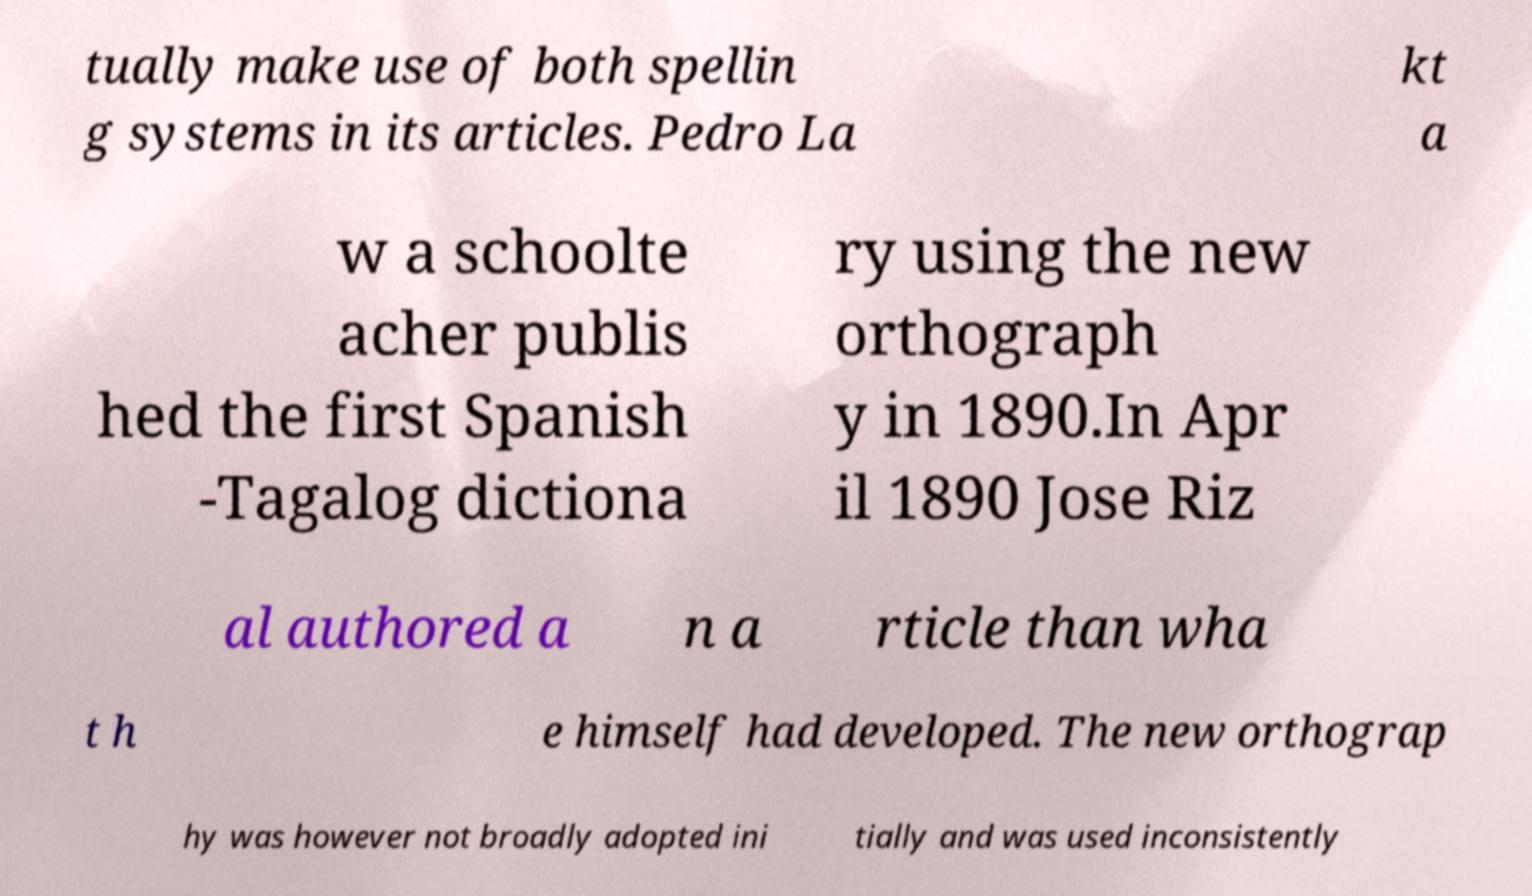Please identify and transcribe the text found in this image. tually make use of both spellin g systems in its articles. Pedro La kt a w a schoolte acher publis hed the first Spanish -Tagalog dictiona ry using the new orthograph y in 1890.In Apr il 1890 Jose Riz al authored a n a rticle than wha t h e himself had developed. The new orthograp hy was however not broadly adopted ini tially and was used inconsistently 